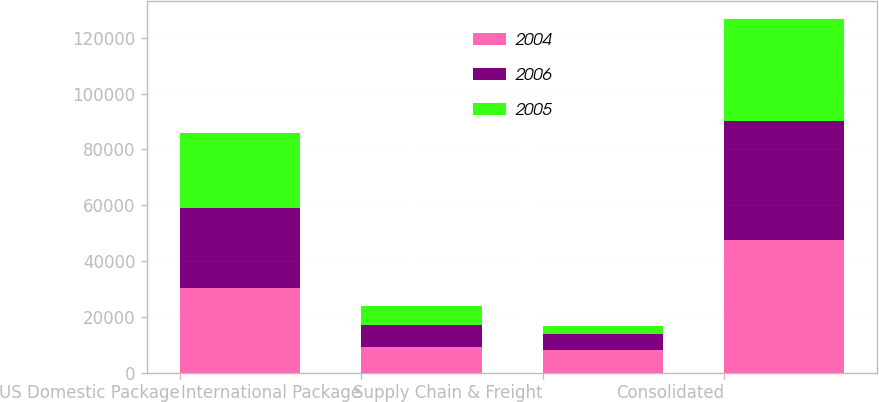Convert chart. <chart><loc_0><loc_0><loc_500><loc_500><stacked_bar_chart><ecel><fcel>US Domestic Package<fcel>International Package<fcel>Supply Chain & Freight<fcel>Consolidated<nl><fcel>2004<fcel>30456<fcel>9089<fcel>8002<fcel>47547<nl><fcel>2006<fcel>28610<fcel>7977<fcel>5994<fcel>42581<nl><fcel>2005<fcel>26960<fcel>6809<fcel>2813<fcel>36582<nl></chart> 